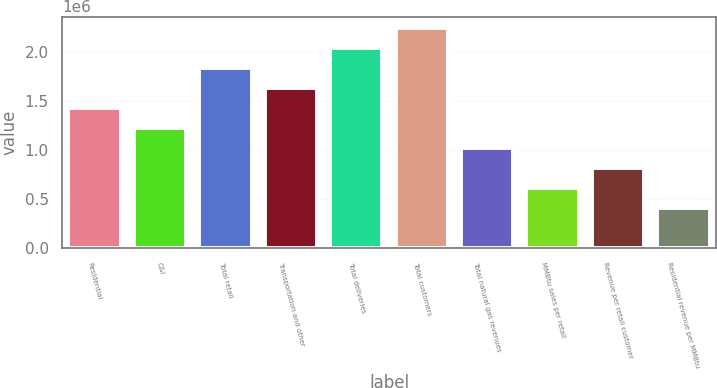Convert chart. <chart><loc_0><loc_0><loc_500><loc_500><bar_chart><fcel>Residential<fcel>C&I<fcel>Total retail<fcel>Transportation and other<fcel>Total deliveries<fcel>Total customers<fcel>Total natural gas revenues<fcel>MMBtu sales per retail<fcel>Revenue per retail customer<fcel>Residential revenue per MMBtu<nl><fcel>1.43147e+06<fcel>1.22697e+06<fcel>1.84046e+06<fcel>1.63596e+06<fcel>2.04495e+06<fcel>2.24945e+06<fcel>1.02248e+06<fcel>613486<fcel>817981<fcel>408991<nl></chart> 